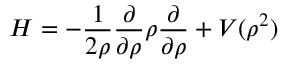Convert formula to latex. <formula><loc_0><loc_0><loc_500><loc_500>H = - \frac { 1 } { 2 \rho } \frac { \partial } { \partial \rho } \rho \frac { \partial } { \partial \rho } + V ( \rho ^ { 2 } )</formula> 